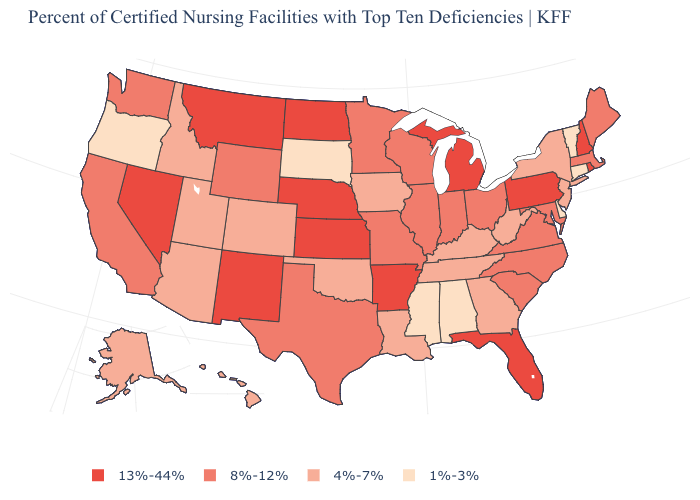Does Michigan have the highest value in the USA?
Write a very short answer. Yes. Does Connecticut have the lowest value in the USA?
Short answer required. Yes. Does the first symbol in the legend represent the smallest category?
Write a very short answer. No. What is the value of Minnesota?
Give a very brief answer. 8%-12%. Name the states that have a value in the range 4%-7%?
Give a very brief answer. Alaska, Arizona, Colorado, Georgia, Hawaii, Idaho, Iowa, Kentucky, Louisiana, New Jersey, New York, Oklahoma, Tennessee, Utah, West Virginia. Name the states that have a value in the range 13%-44%?
Keep it brief. Arkansas, Florida, Kansas, Michigan, Montana, Nebraska, Nevada, New Hampshire, New Mexico, North Dakota, Pennsylvania, Rhode Island. How many symbols are there in the legend?
Be succinct. 4. What is the value of Florida?
Keep it brief. 13%-44%. Does Colorado have the same value as Massachusetts?
Answer briefly. No. Does Maine have a higher value than Mississippi?
Give a very brief answer. Yes. Name the states that have a value in the range 8%-12%?
Concise answer only. California, Illinois, Indiana, Maine, Maryland, Massachusetts, Minnesota, Missouri, North Carolina, Ohio, South Carolina, Texas, Virginia, Washington, Wisconsin, Wyoming. Name the states that have a value in the range 13%-44%?
Write a very short answer. Arkansas, Florida, Kansas, Michigan, Montana, Nebraska, Nevada, New Hampshire, New Mexico, North Dakota, Pennsylvania, Rhode Island. Name the states that have a value in the range 1%-3%?
Write a very short answer. Alabama, Connecticut, Delaware, Mississippi, Oregon, South Dakota, Vermont. Which states have the highest value in the USA?
Give a very brief answer. Arkansas, Florida, Kansas, Michigan, Montana, Nebraska, Nevada, New Hampshire, New Mexico, North Dakota, Pennsylvania, Rhode Island. What is the lowest value in the USA?
Be succinct. 1%-3%. 